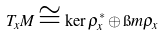Convert formula to latex. <formula><loc_0><loc_0><loc_500><loc_500>T _ { x } M \cong \ker \rho _ { x } ^ { * } \oplus \i m \rho _ { x }</formula> 